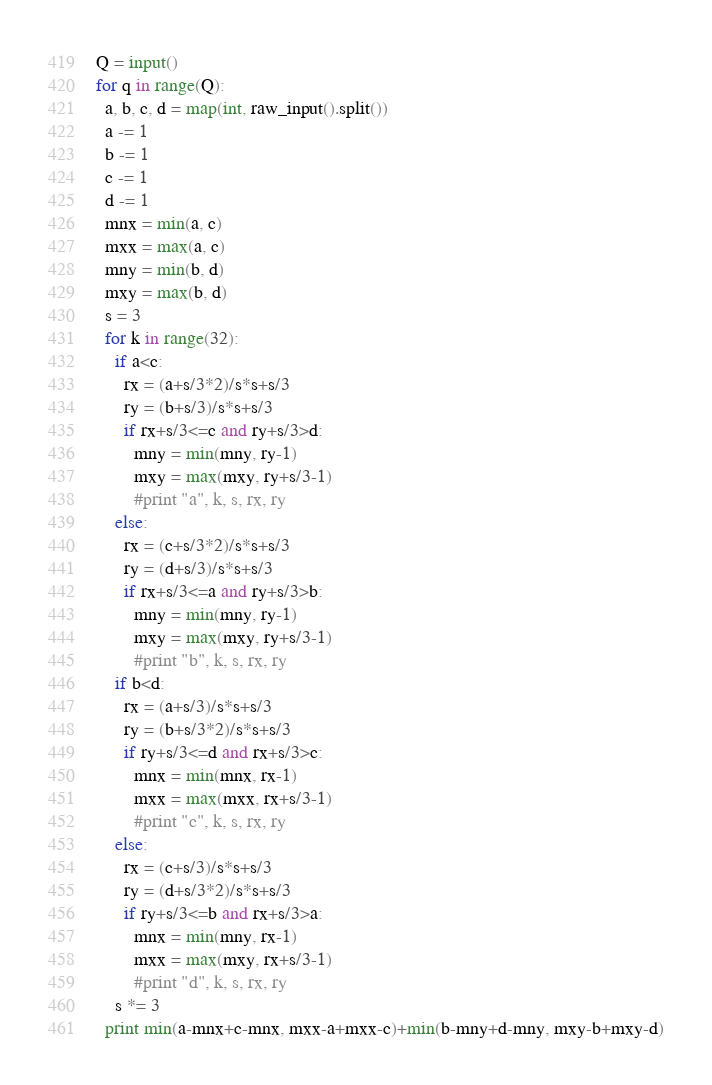Convert code to text. <code><loc_0><loc_0><loc_500><loc_500><_Python_>Q = input()
for q in range(Q):
  a, b, c, d = map(int, raw_input().split())
  a -= 1
  b -= 1
  c -= 1
  d -= 1
  mnx = min(a, c)
  mxx = max(a, c)
  mny = min(b, d)
  mxy = max(b, d)
  s = 3
  for k in range(32):
    if a<c:
      rx = (a+s/3*2)/s*s+s/3
      ry = (b+s/3)/s*s+s/3
      if rx+s/3<=c and ry+s/3>d:
        mny = min(mny, ry-1)
        mxy = max(mxy, ry+s/3-1)
        #print "a", k, s, rx, ry
    else:
      rx = (c+s/3*2)/s*s+s/3
      ry = (d+s/3)/s*s+s/3
      if rx+s/3<=a and ry+s/3>b:
        mny = min(mny, ry-1)
        mxy = max(mxy, ry+s/3-1)
        #print "b", k, s, rx, ry
    if b<d:
      rx = (a+s/3)/s*s+s/3
      ry = (b+s/3*2)/s*s+s/3
      if ry+s/3<=d and rx+s/3>c:
        mnx = min(mnx, rx-1)
        mxx = max(mxx, rx+s/3-1)
        #print "c", k, s, rx, ry
    else:
      rx = (c+s/3)/s*s+s/3
      ry = (d+s/3*2)/s*s+s/3
      if ry+s/3<=b and rx+s/3>a:
        mnx = min(mny, rx-1)
        mxx = max(mxy, rx+s/3-1)
        #print "d", k, s, rx, ry
    s *= 3
  print min(a-mnx+c-mnx, mxx-a+mxx-c)+min(b-mny+d-mny, mxy-b+mxy-d)
</code> 